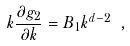Convert formula to latex. <formula><loc_0><loc_0><loc_500><loc_500>k \frac { \partial g _ { 2 } } { \partial k } = B _ { 1 } k ^ { d - 2 } \ ,</formula> 